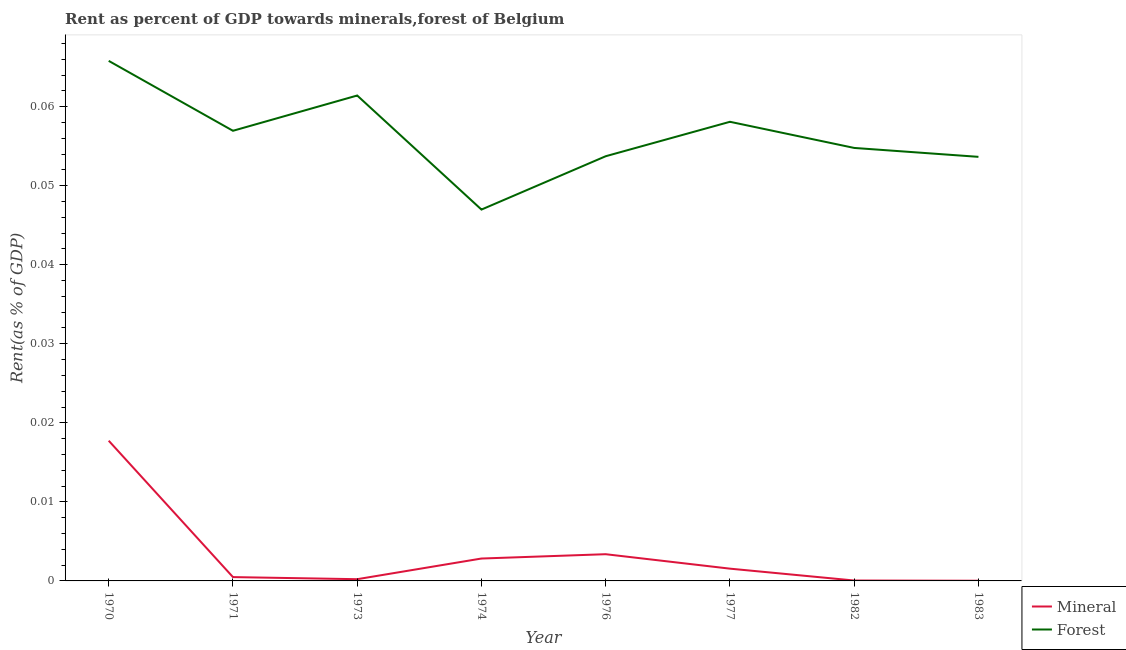Does the line corresponding to mineral rent intersect with the line corresponding to forest rent?
Your answer should be very brief. No. What is the forest rent in 1977?
Offer a terse response. 0.06. Across all years, what is the maximum forest rent?
Your response must be concise. 0.07. Across all years, what is the minimum forest rent?
Provide a succinct answer. 0.05. In which year was the forest rent maximum?
Provide a short and direct response. 1970. In which year was the forest rent minimum?
Offer a terse response. 1974. What is the total forest rent in the graph?
Your answer should be very brief. 0.45. What is the difference between the mineral rent in 1970 and that in 1974?
Your response must be concise. 0.01. What is the difference between the forest rent in 1976 and the mineral rent in 1970?
Make the answer very short. 0.04. What is the average mineral rent per year?
Your answer should be compact. 0. In the year 1970, what is the difference between the forest rent and mineral rent?
Make the answer very short. 0.05. What is the ratio of the forest rent in 1973 to that in 1977?
Your answer should be very brief. 1.06. Is the forest rent in 1970 less than that in 1983?
Provide a short and direct response. No. Is the difference between the forest rent in 1971 and 1982 greater than the difference between the mineral rent in 1971 and 1982?
Your answer should be very brief. Yes. What is the difference between the highest and the second highest forest rent?
Provide a short and direct response. 0. What is the difference between the highest and the lowest mineral rent?
Provide a succinct answer. 0.02. In how many years, is the mineral rent greater than the average mineral rent taken over all years?
Provide a short and direct response. 2. Is the sum of the mineral rent in 1971 and 1976 greater than the maximum forest rent across all years?
Provide a short and direct response. No. Does the forest rent monotonically increase over the years?
Keep it short and to the point. No. How many lines are there?
Your response must be concise. 2. How many years are there in the graph?
Provide a succinct answer. 8. Are the values on the major ticks of Y-axis written in scientific E-notation?
Your response must be concise. No. Does the graph contain any zero values?
Your answer should be compact. No. Does the graph contain grids?
Make the answer very short. No. How are the legend labels stacked?
Offer a very short reply. Vertical. What is the title of the graph?
Ensure brevity in your answer.  Rent as percent of GDP towards minerals,forest of Belgium. Does "Commercial bank branches" appear as one of the legend labels in the graph?
Your answer should be very brief. No. What is the label or title of the X-axis?
Ensure brevity in your answer.  Year. What is the label or title of the Y-axis?
Your answer should be very brief. Rent(as % of GDP). What is the Rent(as % of GDP) of Mineral in 1970?
Offer a very short reply. 0.02. What is the Rent(as % of GDP) of Forest in 1970?
Ensure brevity in your answer.  0.07. What is the Rent(as % of GDP) of Mineral in 1971?
Your answer should be very brief. 0. What is the Rent(as % of GDP) in Forest in 1971?
Your answer should be compact. 0.06. What is the Rent(as % of GDP) of Mineral in 1973?
Offer a very short reply. 0. What is the Rent(as % of GDP) of Forest in 1973?
Make the answer very short. 0.06. What is the Rent(as % of GDP) of Mineral in 1974?
Provide a succinct answer. 0. What is the Rent(as % of GDP) in Forest in 1974?
Give a very brief answer. 0.05. What is the Rent(as % of GDP) in Mineral in 1976?
Give a very brief answer. 0. What is the Rent(as % of GDP) in Forest in 1976?
Your answer should be very brief. 0.05. What is the Rent(as % of GDP) of Mineral in 1977?
Offer a terse response. 0. What is the Rent(as % of GDP) in Forest in 1977?
Ensure brevity in your answer.  0.06. What is the Rent(as % of GDP) of Mineral in 1982?
Make the answer very short. 5.1557649485168e-5. What is the Rent(as % of GDP) of Forest in 1982?
Offer a terse response. 0.05. What is the Rent(as % of GDP) in Mineral in 1983?
Provide a succinct answer. 2.2873388575686e-5. What is the Rent(as % of GDP) of Forest in 1983?
Offer a terse response. 0.05. Across all years, what is the maximum Rent(as % of GDP) of Mineral?
Offer a terse response. 0.02. Across all years, what is the maximum Rent(as % of GDP) in Forest?
Give a very brief answer. 0.07. Across all years, what is the minimum Rent(as % of GDP) of Mineral?
Keep it short and to the point. 2.2873388575686e-5. Across all years, what is the minimum Rent(as % of GDP) of Forest?
Make the answer very short. 0.05. What is the total Rent(as % of GDP) in Mineral in the graph?
Your answer should be very brief. 0.03. What is the total Rent(as % of GDP) of Forest in the graph?
Ensure brevity in your answer.  0.45. What is the difference between the Rent(as % of GDP) of Mineral in 1970 and that in 1971?
Give a very brief answer. 0.02. What is the difference between the Rent(as % of GDP) of Forest in 1970 and that in 1971?
Offer a terse response. 0.01. What is the difference between the Rent(as % of GDP) of Mineral in 1970 and that in 1973?
Make the answer very short. 0.02. What is the difference between the Rent(as % of GDP) in Forest in 1970 and that in 1973?
Provide a short and direct response. 0. What is the difference between the Rent(as % of GDP) in Mineral in 1970 and that in 1974?
Your response must be concise. 0.01. What is the difference between the Rent(as % of GDP) in Forest in 1970 and that in 1974?
Ensure brevity in your answer.  0.02. What is the difference between the Rent(as % of GDP) of Mineral in 1970 and that in 1976?
Your response must be concise. 0.01. What is the difference between the Rent(as % of GDP) in Forest in 1970 and that in 1976?
Provide a short and direct response. 0.01. What is the difference between the Rent(as % of GDP) of Mineral in 1970 and that in 1977?
Make the answer very short. 0.02. What is the difference between the Rent(as % of GDP) of Forest in 1970 and that in 1977?
Offer a very short reply. 0.01. What is the difference between the Rent(as % of GDP) of Mineral in 1970 and that in 1982?
Make the answer very short. 0.02. What is the difference between the Rent(as % of GDP) of Forest in 1970 and that in 1982?
Your response must be concise. 0.01. What is the difference between the Rent(as % of GDP) in Mineral in 1970 and that in 1983?
Your response must be concise. 0.02. What is the difference between the Rent(as % of GDP) in Forest in 1970 and that in 1983?
Make the answer very short. 0.01. What is the difference between the Rent(as % of GDP) of Forest in 1971 and that in 1973?
Offer a very short reply. -0. What is the difference between the Rent(as % of GDP) in Mineral in 1971 and that in 1974?
Offer a very short reply. -0. What is the difference between the Rent(as % of GDP) in Forest in 1971 and that in 1974?
Provide a succinct answer. 0.01. What is the difference between the Rent(as % of GDP) of Mineral in 1971 and that in 1976?
Ensure brevity in your answer.  -0. What is the difference between the Rent(as % of GDP) of Forest in 1971 and that in 1976?
Offer a very short reply. 0. What is the difference between the Rent(as % of GDP) of Mineral in 1971 and that in 1977?
Give a very brief answer. -0. What is the difference between the Rent(as % of GDP) in Forest in 1971 and that in 1977?
Your answer should be very brief. -0. What is the difference between the Rent(as % of GDP) in Mineral in 1971 and that in 1982?
Provide a succinct answer. 0. What is the difference between the Rent(as % of GDP) in Forest in 1971 and that in 1982?
Offer a terse response. 0. What is the difference between the Rent(as % of GDP) of Mineral in 1971 and that in 1983?
Offer a very short reply. 0. What is the difference between the Rent(as % of GDP) in Forest in 1971 and that in 1983?
Ensure brevity in your answer.  0. What is the difference between the Rent(as % of GDP) in Mineral in 1973 and that in 1974?
Ensure brevity in your answer.  -0. What is the difference between the Rent(as % of GDP) of Forest in 1973 and that in 1974?
Provide a short and direct response. 0.01. What is the difference between the Rent(as % of GDP) in Mineral in 1973 and that in 1976?
Provide a succinct answer. -0. What is the difference between the Rent(as % of GDP) in Forest in 1973 and that in 1976?
Your answer should be compact. 0.01. What is the difference between the Rent(as % of GDP) in Mineral in 1973 and that in 1977?
Your answer should be very brief. -0. What is the difference between the Rent(as % of GDP) in Forest in 1973 and that in 1977?
Provide a short and direct response. 0. What is the difference between the Rent(as % of GDP) of Mineral in 1973 and that in 1982?
Provide a succinct answer. 0. What is the difference between the Rent(as % of GDP) in Forest in 1973 and that in 1982?
Your answer should be very brief. 0.01. What is the difference between the Rent(as % of GDP) in Mineral in 1973 and that in 1983?
Offer a very short reply. 0. What is the difference between the Rent(as % of GDP) in Forest in 1973 and that in 1983?
Your answer should be very brief. 0.01. What is the difference between the Rent(as % of GDP) in Mineral in 1974 and that in 1976?
Offer a very short reply. -0. What is the difference between the Rent(as % of GDP) in Forest in 1974 and that in 1976?
Your response must be concise. -0.01. What is the difference between the Rent(as % of GDP) of Mineral in 1974 and that in 1977?
Offer a very short reply. 0. What is the difference between the Rent(as % of GDP) in Forest in 1974 and that in 1977?
Offer a terse response. -0.01. What is the difference between the Rent(as % of GDP) of Mineral in 1974 and that in 1982?
Make the answer very short. 0. What is the difference between the Rent(as % of GDP) of Forest in 1974 and that in 1982?
Your answer should be very brief. -0.01. What is the difference between the Rent(as % of GDP) of Mineral in 1974 and that in 1983?
Your answer should be compact. 0. What is the difference between the Rent(as % of GDP) of Forest in 1974 and that in 1983?
Your response must be concise. -0.01. What is the difference between the Rent(as % of GDP) in Mineral in 1976 and that in 1977?
Offer a very short reply. 0. What is the difference between the Rent(as % of GDP) of Forest in 1976 and that in 1977?
Offer a terse response. -0. What is the difference between the Rent(as % of GDP) of Mineral in 1976 and that in 1982?
Ensure brevity in your answer.  0. What is the difference between the Rent(as % of GDP) of Forest in 1976 and that in 1982?
Your response must be concise. -0. What is the difference between the Rent(as % of GDP) in Mineral in 1976 and that in 1983?
Provide a short and direct response. 0. What is the difference between the Rent(as % of GDP) of Forest in 1976 and that in 1983?
Provide a short and direct response. 0. What is the difference between the Rent(as % of GDP) in Mineral in 1977 and that in 1982?
Make the answer very short. 0. What is the difference between the Rent(as % of GDP) in Forest in 1977 and that in 1982?
Keep it short and to the point. 0. What is the difference between the Rent(as % of GDP) of Mineral in 1977 and that in 1983?
Keep it short and to the point. 0. What is the difference between the Rent(as % of GDP) in Forest in 1977 and that in 1983?
Offer a terse response. 0. What is the difference between the Rent(as % of GDP) in Mineral in 1982 and that in 1983?
Give a very brief answer. 0. What is the difference between the Rent(as % of GDP) of Forest in 1982 and that in 1983?
Your response must be concise. 0. What is the difference between the Rent(as % of GDP) in Mineral in 1970 and the Rent(as % of GDP) in Forest in 1971?
Keep it short and to the point. -0.04. What is the difference between the Rent(as % of GDP) in Mineral in 1970 and the Rent(as % of GDP) in Forest in 1973?
Offer a terse response. -0.04. What is the difference between the Rent(as % of GDP) in Mineral in 1970 and the Rent(as % of GDP) in Forest in 1974?
Your answer should be very brief. -0.03. What is the difference between the Rent(as % of GDP) in Mineral in 1970 and the Rent(as % of GDP) in Forest in 1976?
Your answer should be very brief. -0.04. What is the difference between the Rent(as % of GDP) of Mineral in 1970 and the Rent(as % of GDP) of Forest in 1977?
Offer a very short reply. -0.04. What is the difference between the Rent(as % of GDP) of Mineral in 1970 and the Rent(as % of GDP) of Forest in 1982?
Your response must be concise. -0.04. What is the difference between the Rent(as % of GDP) in Mineral in 1970 and the Rent(as % of GDP) in Forest in 1983?
Your answer should be compact. -0.04. What is the difference between the Rent(as % of GDP) in Mineral in 1971 and the Rent(as % of GDP) in Forest in 1973?
Your answer should be very brief. -0.06. What is the difference between the Rent(as % of GDP) of Mineral in 1971 and the Rent(as % of GDP) of Forest in 1974?
Ensure brevity in your answer.  -0.05. What is the difference between the Rent(as % of GDP) of Mineral in 1971 and the Rent(as % of GDP) of Forest in 1976?
Give a very brief answer. -0.05. What is the difference between the Rent(as % of GDP) in Mineral in 1971 and the Rent(as % of GDP) in Forest in 1977?
Make the answer very short. -0.06. What is the difference between the Rent(as % of GDP) of Mineral in 1971 and the Rent(as % of GDP) of Forest in 1982?
Make the answer very short. -0.05. What is the difference between the Rent(as % of GDP) in Mineral in 1971 and the Rent(as % of GDP) in Forest in 1983?
Ensure brevity in your answer.  -0.05. What is the difference between the Rent(as % of GDP) of Mineral in 1973 and the Rent(as % of GDP) of Forest in 1974?
Your response must be concise. -0.05. What is the difference between the Rent(as % of GDP) in Mineral in 1973 and the Rent(as % of GDP) in Forest in 1976?
Make the answer very short. -0.05. What is the difference between the Rent(as % of GDP) of Mineral in 1973 and the Rent(as % of GDP) of Forest in 1977?
Your answer should be compact. -0.06. What is the difference between the Rent(as % of GDP) in Mineral in 1973 and the Rent(as % of GDP) in Forest in 1982?
Provide a succinct answer. -0.05. What is the difference between the Rent(as % of GDP) of Mineral in 1973 and the Rent(as % of GDP) of Forest in 1983?
Ensure brevity in your answer.  -0.05. What is the difference between the Rent(as % of GDP) in Mineral in 1974 and the Rent(as % of GDP) in Forest in 1976?
Give a very brief answer. -0.05. What is the difference between the Rent(as % of GDP) of Mineral in 1974 and the Rent(as % of GDP) of Forest in 1977?
Ensure brevity in your answer.  -0.06. What is the difference between the Rent(as % of GDP) of Mineral in 1974 and the Rent(as % of GDP) of Forest in 1982?
Your answer should be very brief. -0.05. What is the difference between the Rent(as % of GDP) of Mineral in 1974 and the Rent(as % of GDP) of Forest in 1983?
Ensure brevity in your answer.  -0.05. What is the difference between the Rent(as % of GDP) of Mineral in 1976 and the Rent(as % of GDP) of Forest in 1977?
Your answer should be very brief. -0.05. What is the difference between the Rent(as % of GDP) of Mineral in 1976 and the Rent(as % of GDP) of Forest in 1982?
Your response must be concise. -0.05. What is the difference between the Rent(as % of GDP) of Mineral in 1976 and the Rent(as % of GDP) of Forest in 1983?
Provide a succinct answer. -0.05. What is the difference between the Rent(as % of GDP) in Mineral in 1977 and the Rent(as % of GDP) in Forest in 1982?
Keep it short and to the point. -0.05. What is the difference between the Rent(as % of GDP) of Mineral in 1977 and the Rent(as % of GDP) of Forest in 1983?
Provide a short and direct response. -0.05. What is the difference between the Rent(as % of GDP) of Mineral in 1982 and the Rent(as % of GDP) of Forest in 1983?
Keep it short and to the point. -0.05. What is the average Rent(as % of GDP) in Mineral per year?
Give a very brief answer. 0. What is the average Rent(as % of GDP) of Forest per year?
Offer a terse response. 0.06. In the year 1970, what is the difference between the Rent(as % of GDP) of Mineral and Rent(as % of GDP) of Forest?
Give a very brief answer. -0.05. In the year 1971, what is the difference between the Rent(as % of GDP) in Mineral and Rent(as % of GDP) in Forest?
Your response must be concise. -0.06. In the year 1973, what is the difference between the Rent(as % of GDP) in Mineral and Rent(as % of GDP) in Forest?
Your answer should be very brief. -0.06. In the year 1974, what is the difference between the Rent(as % of GDP) of Mineral and Rent(as % of GDP) of Forest?
Provide a succinct answer. -0.04. In the year 1976, what is the difference between the Rent(as % of GDP) of Mineral and Rent(as % of GDP) of Forest?
Offer a very short reply. -0.05. In the year 1977, what is the difference between the Rent(as % of GDP) in Mineral and Rent(as % of GDP) in Forest?
Ensure brevity in your answer.  -0.06. In the year 1982, what is the difference between the Rent(as % of GDP) of Mineral and Rent(as % of GDP) of Forest?
Provide a short and direct response. -0.05. In the year 1983, what is the difference between the Rent(as % of GDP) of Mineral and Rent(as % of GDP) of Forest?
Give a very brief answer. -0.05. What is the ratio of the Rent(as % of GDP) in Mineral in 1970 to that in 1971?
Make the answer very short. 36.67. What is the ratio of the Rent(as % of GDP) of Forest in 1970 to that in 1971?
Make the answer very short. 1.16. What is the ratio of the Rent(as % of GDP) of Mineral in 1970 to that in 1973?
Ensure brevity in your answer.  80.74. What is the ratio of the Rent(as % of GDP) in Forest in 1970 to that in 1973?
Your answer should be compact. 1.07. What is the ratio of the Rent(as % of GDP) in Mineral in 1970 to that in 1974?
Provide a short and direct response. 6.26. What is the ratio of the Rent(as % of GDP) of Forest in 1970 to that in 1974?
Give a very brief answer. 1.4. What is the ratio of the Rent(as % of GDP) in Mineral in 1970 to that in 1976?
Ensure brevity in your answer.  5.25. What is the ratio of the Rent(as % of GDP) of Forest in 1970 to that in 1976?
Provide a succinct answer. 1.22. What is the ratio of the Rent(as % of GDP) of Mineral in 1970 to that in 1977?
Your answer should be compact. 11.43. What is the ratio of the Rent(as % of GDP) of Forest in 1970 to that in 1977?
Provide a succinct answer. 1.13. What is the ratio of the Rent(as % of GDP) of Mineral in 1970 to that in 1982?
Your answer should be very brief. 344.05. What is the ratio of the Rent(as % of GDP) in Forest in 1970 to that in 1982?
Offer a very short reply. 1.2. What is the ratio of the Rent(as % of GDP) of Mineral in 1970 to that in 1983?
Offer a very short reply. 775.51. What is the ratio of the Rent(as % of GDP) in Forest in 1970 to that in 1983?
Your answer should be compact. 1.23. What is the ratio of the Rent(as % of GDP) of Mineral in 1971 to that in 1973?
Your response must be concise. 2.2. What is the ratio of the Rent(as % of GDP) of Forest in 1971 to that in 1973?
Provide a short and direct response. 0.93. What is the ratio of the Rent(as % of GDP) in Mineral in 1971 to that in 1974?
Make the answer very short. 0.17. What is the ratio of the Rent(as % of GDP) of Forest in 1971 to that in 1974?
Provide a succinct answer. 1.21. What is the ratio of the Rent(as % of GDP) of Mineral in 1971 to that in 1976?
Your answer should be compact. 0.14. What is the ratio of the Rent(as % of GDP) of Forest in 1971 to that in 1976?
Your answer should be compact. 1.06. What is the ratio of the Rent(as % of GDP) in Mineral in 1971 to that in 1977?
Offer a very short reply. 0.31. What is the ratio of the Rent(as % of GDP) of Forest in 1971 to that in 1977?
Give a very brief answer. 0.98. What is the ratio of the Rent(as % of GDP) of Mineral in 1971 to that in 1982?
Make the answer very short. 9.38. What is the ratio of the Rent(as % of GDP) in Forest in 1971 to that in 1982?
Ensure brevity in your answer.  1.04. What is the ratio of the Rent(as % of GDP) of Mineral in 1971 to that in 1983?
Your answer should be compact. 21.15. What is the ratio of the Rent(as % of GDP) of Forest in 1971 to that in 1983?
Your answer should be compact. 1.06. What is the ratio of the Rent(as % of GDP) of Mineral in 1973 to that in 1974?
Your answer should be compact. 0.08. What is the ratio of the Rent(as % of GDP) of Forest in 1973 to that in 1974?
Give a very brief answer. 1.31. What is the ratio of the Rent(as % of GDP) of Mineral in 1973 to that in 1976?
Make the answer very short. 0.07. What is the ratio of the Rent(as % of GDP) in Mineral in 1973 to that in 1977?
Give a very brief answer. 0.14. What is the ratio of the Rent(as % of GDP) of Forest in 1973 to that in 1977?
Offer a terse response. 1.06. What is the ratio of the Rent(as % of GDP) of Mineral in 1973 to that in 1982?
Give a very brief answer. 4.26. What is the ratio of the Rent(as % of GDP) in Forest in 1973 to that in 1982?
Ensure brevity in your answer.  1.12. What is the ratio of the Rent(as % of GDP) in Mineral in 1973 to that in 1983?
Your response must be concise. 9.61. What is the ratio of the Rent(as % of GDP) of Forest in 1973 to that in 1983?
Give a very brief answer. 1.14. What is the ratio of the Rent(as % of GDP) of Mineral in 1974 to that in 1976?
Your response must be concise. 0.84. What is the ratio of the Rent(as % of GDP) in Forest in 1974 to that in 1976?
Offer a very short reply. 0.87. What is the ratio of the Rent(as % of GDP) in Mineral in 1974 to that in 1977?
Keep it short and to the point. 1.83. What is the ratio of the Rent(as % of GDP) in Forest in 1974 to that in 1977?
Offer a terse response. 0.81. What is the ratio of the Rent(as % of GDP) of Mineral in 1974 to that in 1982?
Offer a very short reply. 54.96. What is the ratio of the Rent(as % of GDP) of Forest in 1974 to that in 1982?
Provide a succinct answer. 0.86. What is the ratio of the Rent(as % of GDP) in Mineral in 1974 to that in 1983?
Provide a short and direct response. 123.88. What is the ratio of the Rent(as % of GDP) in Forest in 1974 to that in 1983?
Provide a short and direct response. 0.88. What is the ratio of the Rent(as % of GDP) in Mineral in 1976 to that in 1977?
Give a very brief answer. 2.18. What is the ratio of the Rent(as % of GDP) in Forest in 1976 to that in 1977?
Make the answer very short. 0.93. What is the ratio of the Rent(as % of GDP) of Mineral in 1976 to that in 1982?
Your response must be concise. 65.55. What is the ratio of the Rent(as % of GDP) in Forest in 1976 to that in 1982?
Provide a succinct answer. 0.98. What is the ratio of the Rent(as % of GDP) in Mineral in 1976 to that in 1983?
Your answer should be compact. 147.76. What is the ratio of the Rent(as % of GDP) in Mineral in 1977 to that in 1982?
Your response must be concise. 30.1. What is the ratio of the Rent(as % of GDP) in Forest in 1977 to that in 1982?
Make the answer very short. 1.06. What is the ratio of the Rent(as % of GDP) in Mineral in 1977 to that in 1983?
Provide a succinct answer. 67.84. What is the ratio of the Rent(as % of GDP) of Forest in 1977 to that in 1983?
Your answer should be very brief. 1.08. What is the ratio of the Rent(as % of GDP) of Mineral in 1982 to that in 1983?
Your response must be concise. 2.25. What is the ratio of the Rent(as % of GDP) in Forest in 1982 to that in 1983?
Offer a very short reply. 1.02. What is the difference between the highest and the second highest Rent(as % of GDP) of Mineral?
Give a very brief answer. 0.01. What is the difference between the highest and the second highest Rent(as % of GDP) of Forest?
Your response must be concise. 0. What is the difference between the highest and the lowest Rent(as % of GDP) of Mineral?
Offer a terse response. 0.02. What is the difference between the highest and the lowest Rent(as % of GDP) in Forest?
Offer a terse response. 0.02. 